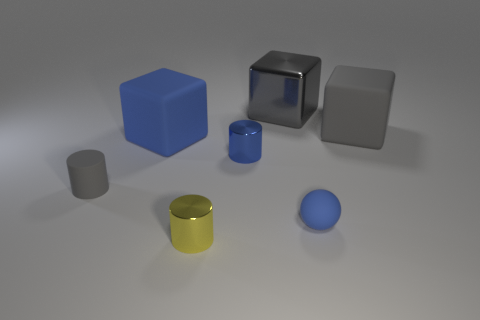What can you tell me about the colors in this image? The image features a relatively muted color palette with the exception of the blue cube and yellow cylinder, which stand out. The other items have subdued hues, such as grey for the cubes and the small cylinder, and olive for the sphere. The background is a neutral white, which doesn't compete with the objects for attention. 